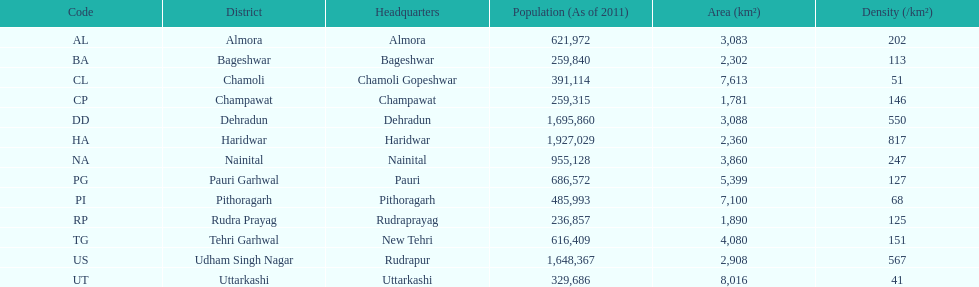After haridwar, which district has the next largest population? Dehradun. 